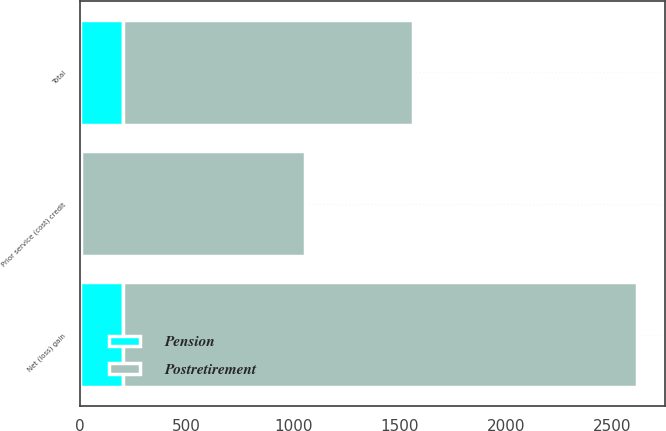<chart> <loc_0><loc_0><loc_500><loc_500><stacked_bar_chart><ecel><fcel>Prior service (cost) credit<fcel>Net (loss) gain<fcel>Total<nl><fcel>Postretirement<fcel>1054<fcel>2417<fcel>1363<nl><fcel>Pension<fcel>2<fcel>200<fcel>202<nl></chart> 